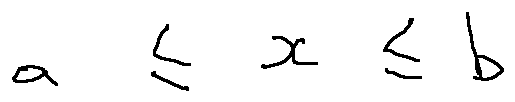Convert formula to latex. <formula><loc_0><loc_0><loc_500><loc_500>a \leq x \leq b</formula> 